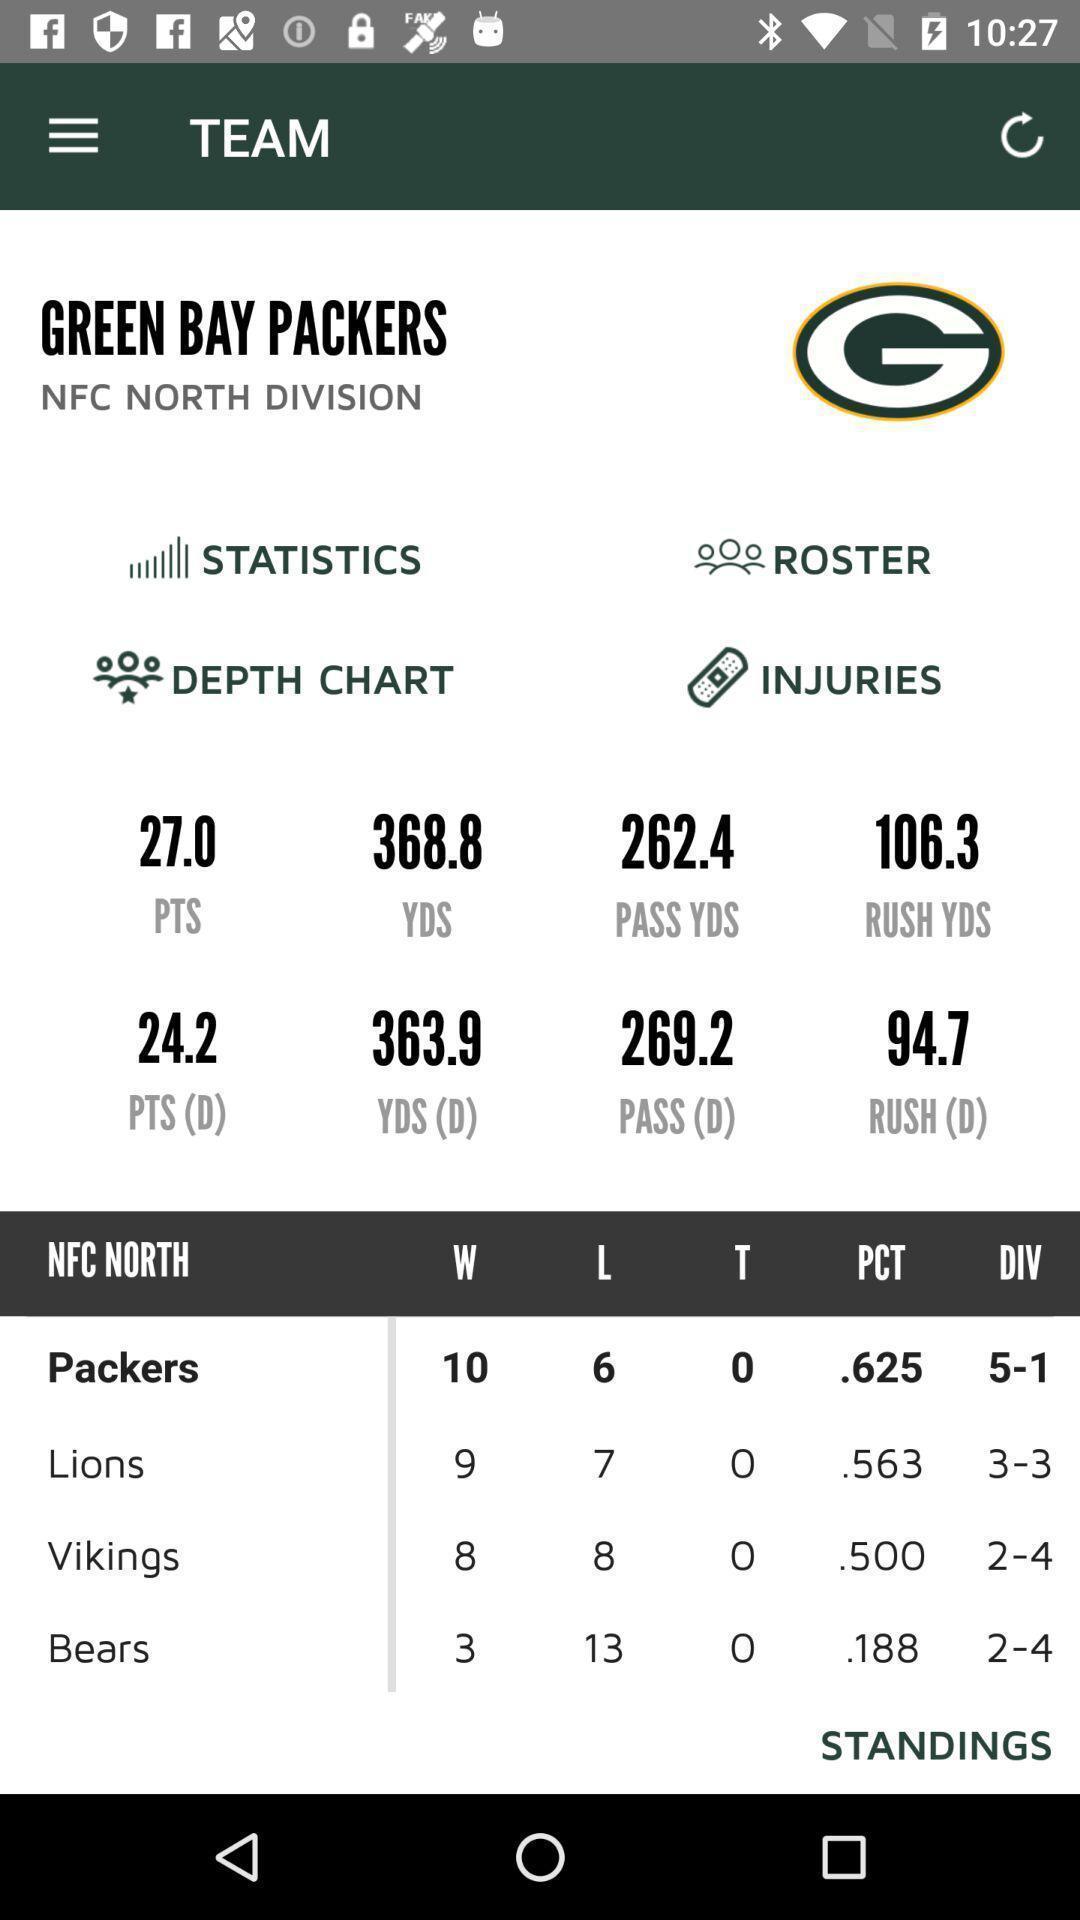Please provide a description for this image. Screen showing team. 